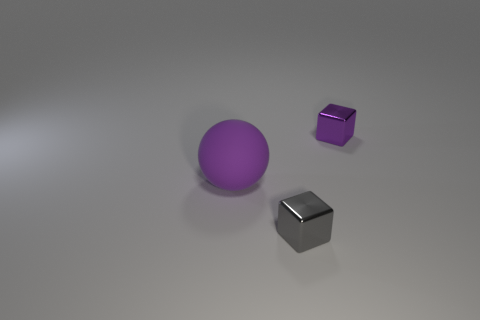Is there anything else that is the same material as the big purple thing?
Keep it short and to the point. No. There is a thing that is in front of the tiny purple thing and to the right of the large ball; what material is it made of?
Offer a terse response. Metal. What number of things are purple objects that are behind the big matte ball or purple matte things?
Offer a very short reply. 2. Are there any brown spheres that have the same size as the purple rubber ball?
Offer a terse response. No. What number of small cubes are both behind the purple matte object and in front of the sphere?
Offer a terse response. 0. What number of large purple spheres are right of the large object?
Offer a very short reply. 0. Are there any tiny brown matte things that have the same shape as the purple metallic object?
Offer a terse response. No. There is a big purple matte thing; is it the same shape as the metal object that is behind the big rubber ball?
Make the answer very short. No. How many spheres are either tiny purple metal objects or gray objects?
Your answer should be compact. 0. There is a small thing in front of the tiny purple metallic object; what shape is it?
Give a very brief answer. Cube. 